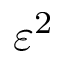Convert formula to latex. <formula><loc_0><loc_0><loc_500><loc_500>\varepsilon ^ { 2 }</formula> 